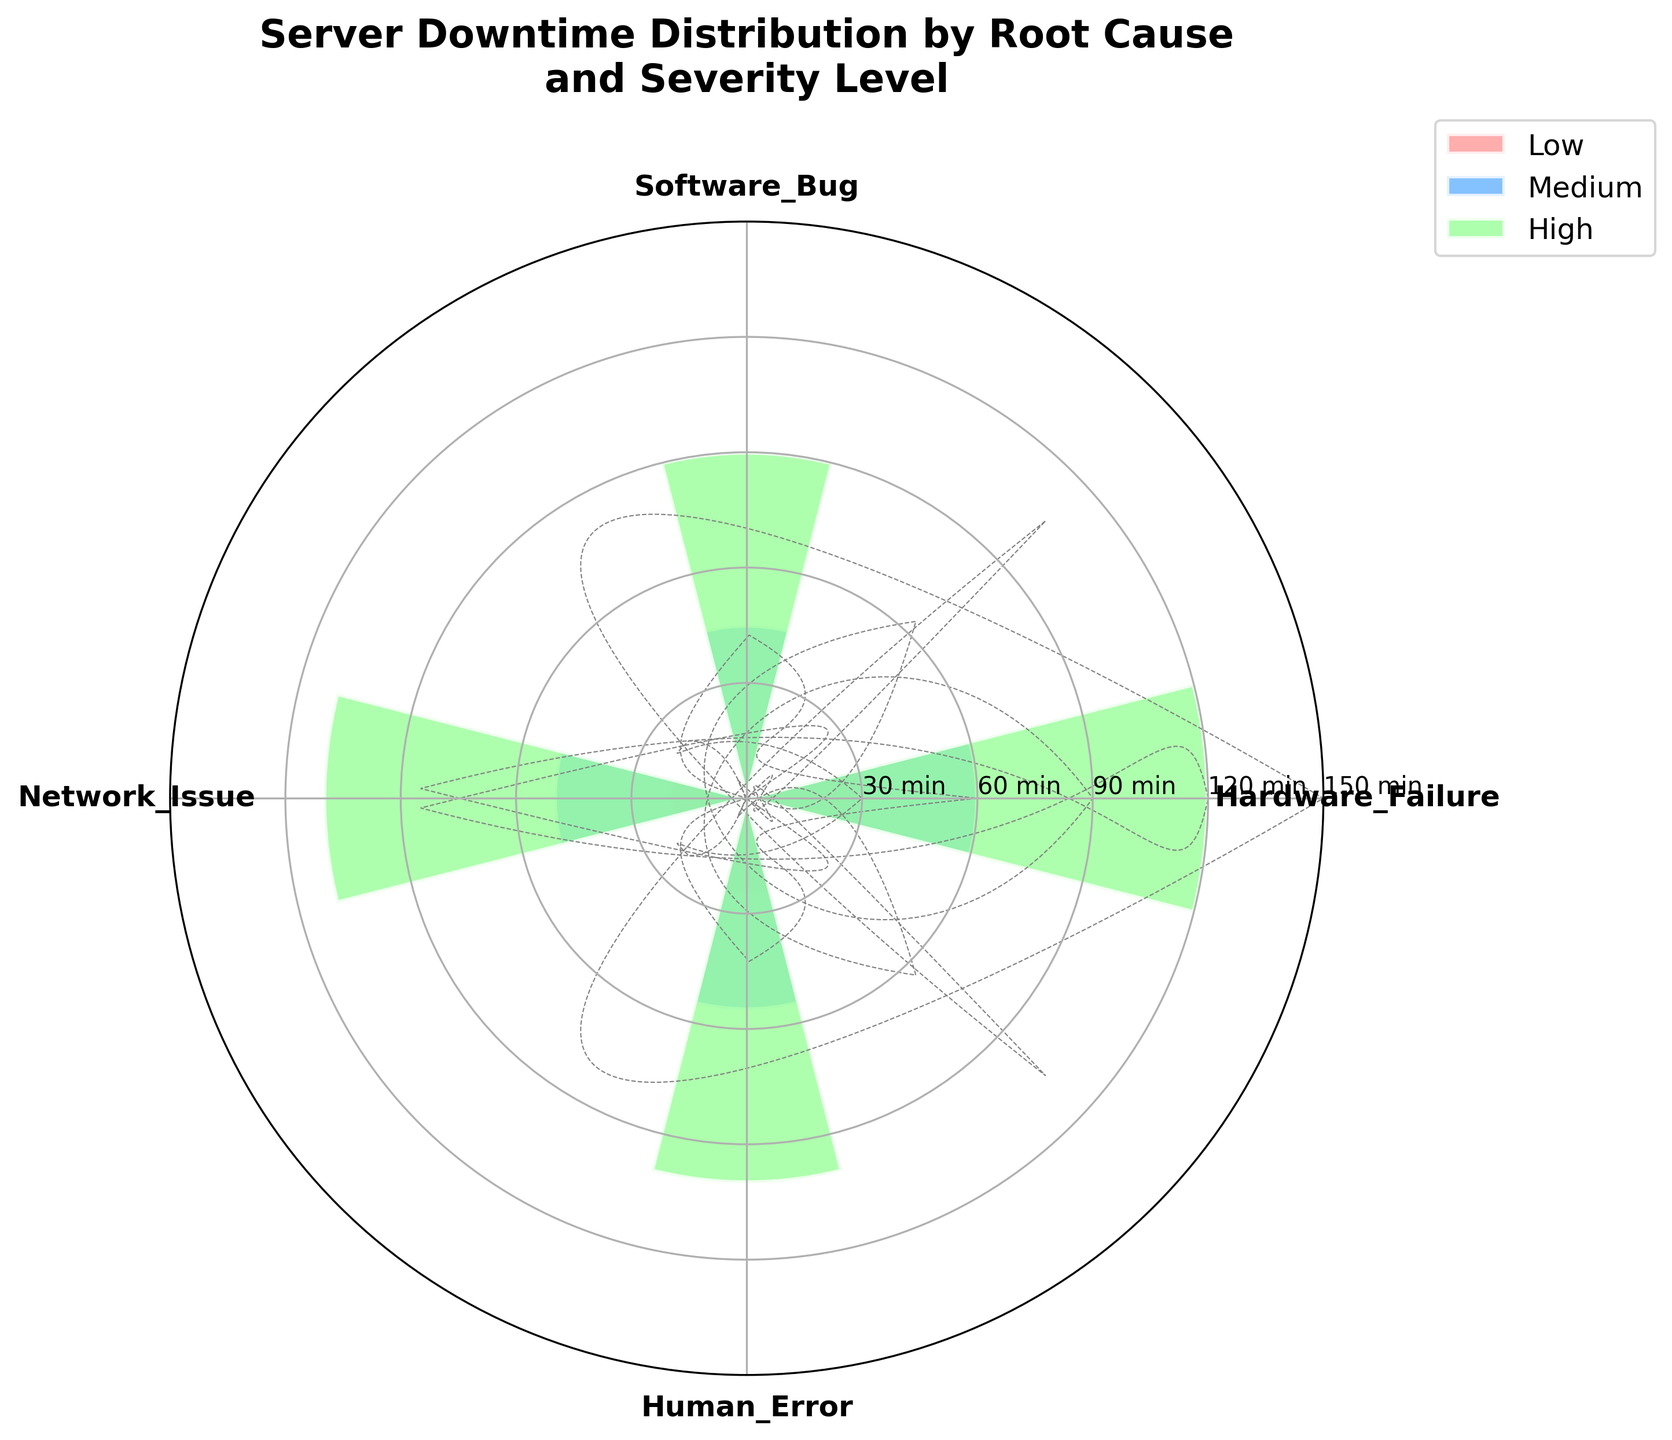How many root causes are displayed in the chart? The chart has axes corresponding to each root cause. We can count these to find the number of root causes.
Answer: 4 What is the title of the chart? The text at the top of the chart usually gives the title. It provides context for what is displayed.
Answer: Server Downtime Distribution by Root Cause and Severity Level Which root cause has the highest downtime in the High severity level? Look at the bars associated with the High severity level and find the root cause with the longest bar.
Answer: Hardware Failure What's the total downtime for Software Bug across all severity levels? Sum the downtime values for Software Bug at Low, Medium, and High severity levels: 15 + 45 + 90 = 150 minutes.
Answer: 150 minutes Compare the downtimes between Network Issue and Human Error in the Medium severity level. Which one is higher? Check the bars at the Medium severity level for these root causes and compare their lengths.
Answer: Human Error Which severity level uses the color #FF9999? Identify the color #FF9999 on the chart legend and note which severity level it corresponds to.
Answer: Low Which root cause has the smallest total downtime across all severity levels? Sum the downtime values for each root cause and find the least: Hardware Failure (30 + 60 + 120), Software Bug (15 + 45 + 90), Network Issue (20 + 50 + 110), Human Error (25 + 55 + 100). Software Bug is smallest at 150 minutes.
Answer: Software Bug What is the average downtime for High severity level across all root causes? Add the High severity level downtimes for all root causes and divide by the number of root causes: (120 + 90 + 110 + 100) / 4 = 105 minutes.
Answer: 105 minutes Based on the chart, which root cause has the highest total downtime? Sum the downtime durations for all severity levels per root cause and identify the highest: Hardware Failure (210), Software Bug (150), Network Issue (180), Human Error (180). Hardware Failure is highest.
Answer: Hardware Failure Considering all severity levels, which root cause has the most even distribution of downtime across severity levels? Compare the downtime deviations for each severity level per root cause. Find the root cause where the values show the smallest disparity: Hardware Failure (30, 60, 120), Software Bug (15, 45, 90), Network Issue (20, 50, 110), Human Error (25, 55, 100). Human Error has more evenly distributed values.
Answer: Human Error 